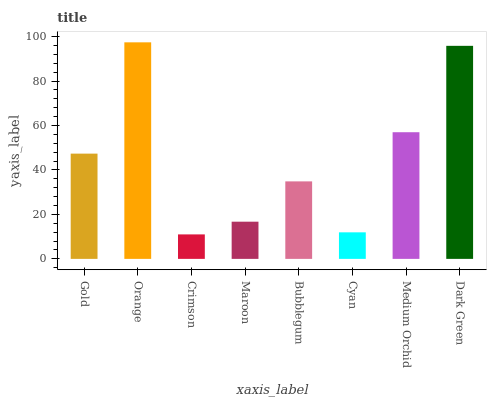Is Crimson the minimum?
Answer yes or no. Yes. Is Orange the maximum?
Answer yes or no. Yes. Is Orange the minimum?
Answer yes or no. No. Is Crimson the maximum?
Answer yes or no. No. Is Orange greater than Crimson?
Answer yes or no. Yes. Is Crimson less than Orange?
Answer yes or no. Yes. Is Crimson greater than Orange?
Answer yes or no. No. Is Orange less than Crimson?
Answer yes or no. No. Is Gold the high median?
Answer yes or no. Yes. Is Bubblegum the low median?
Answer yes or no. Yes. Is Maroon the high median?
Answer yes or no. No. Is Gold the low median?
Answer yes or no. No. 